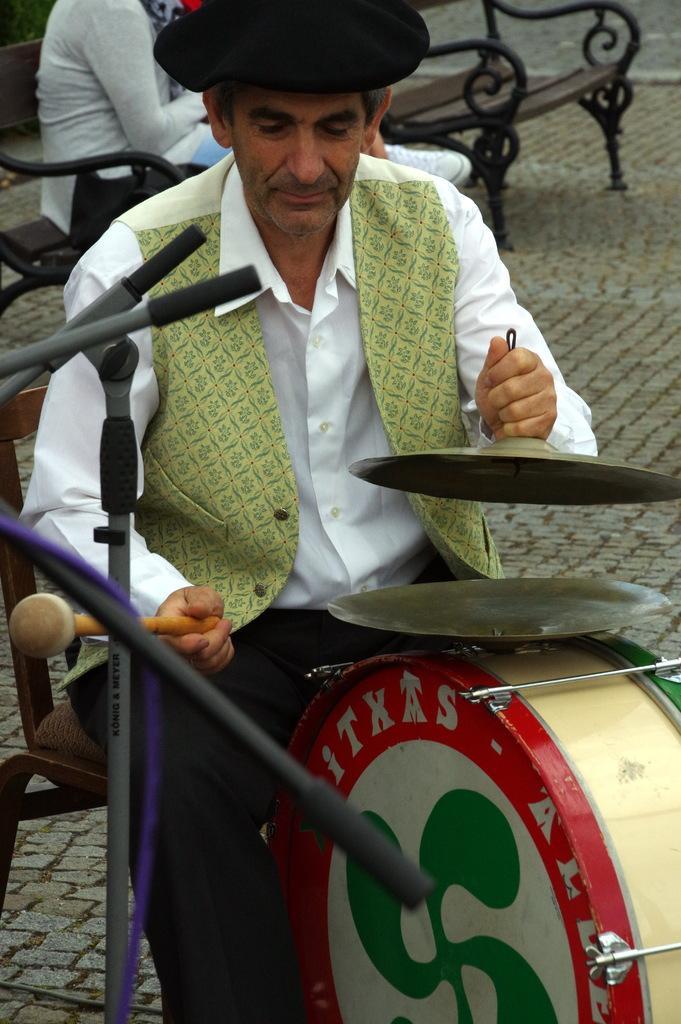Please provide a concise description of this image. man sitting on the chair playing musical instrument,person sitting on the chair. 